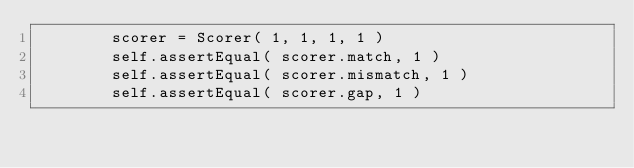<code> <loc_0><loc_0><loc_500><loc_500><_Python_>        scorer = Scorer( 1, 1, 1, 1 )
        self.assertEqual( scorer.match, 1 )
        self.assertEqual( scorer.mismatch, 1 )
        self.assertEqual( scorer.gap, 1 )</code> 